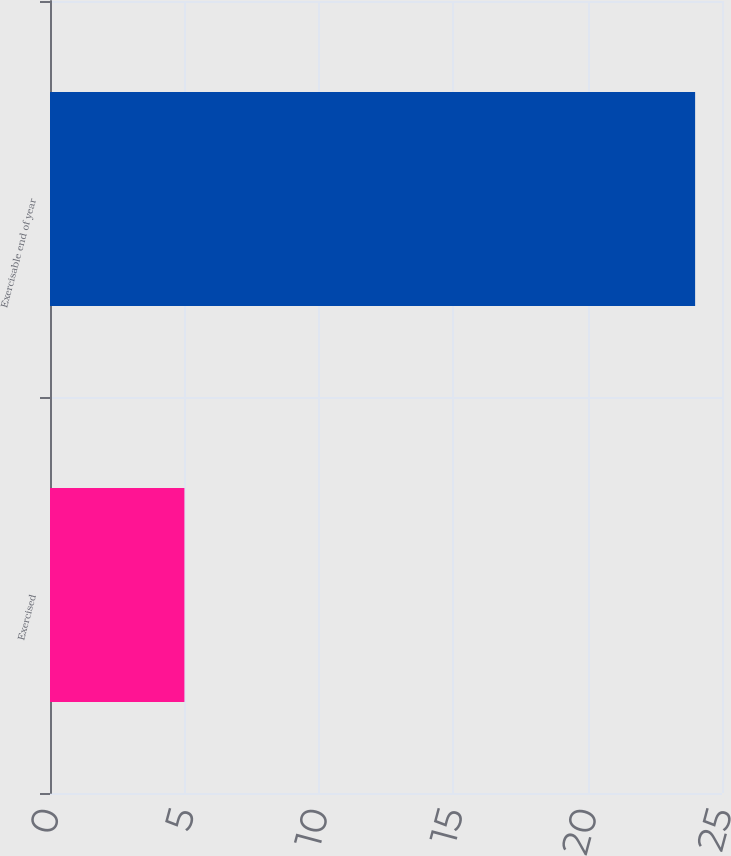Convert chart to OTSL. <chart><loc_0><loc_0><loc_500><loc_500><bar_chart><fcel>Exercised<fcel>Exercisable end of year<nl><fcel>5<fcel>24<nl></chart> 